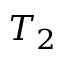Convert formula to latex. <formula><loc_0><loc_0><loc_500><loc_500>T _ { 2 }</formula> 